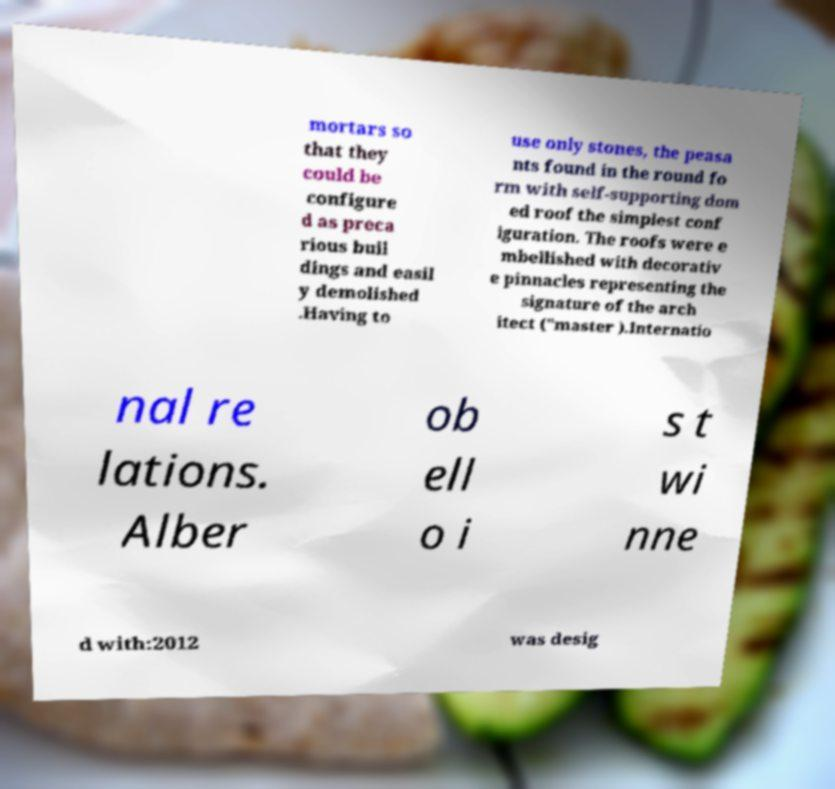I need the written content from this picture converted into text. Can you do that? mortars so that they could be configure d as preca rious buil dings and easil y demolished .Having to use only stones, the peasa nts found in the round fo rm with self-supporting dom ed roof the simplest conf iguration. The roofs were e mbellished with decorativ e pinnacles representing the signature of the arch itect ("master ).Internatio nal re lations. Alber ob ell o i s t wi nne d with:2012 was desig 